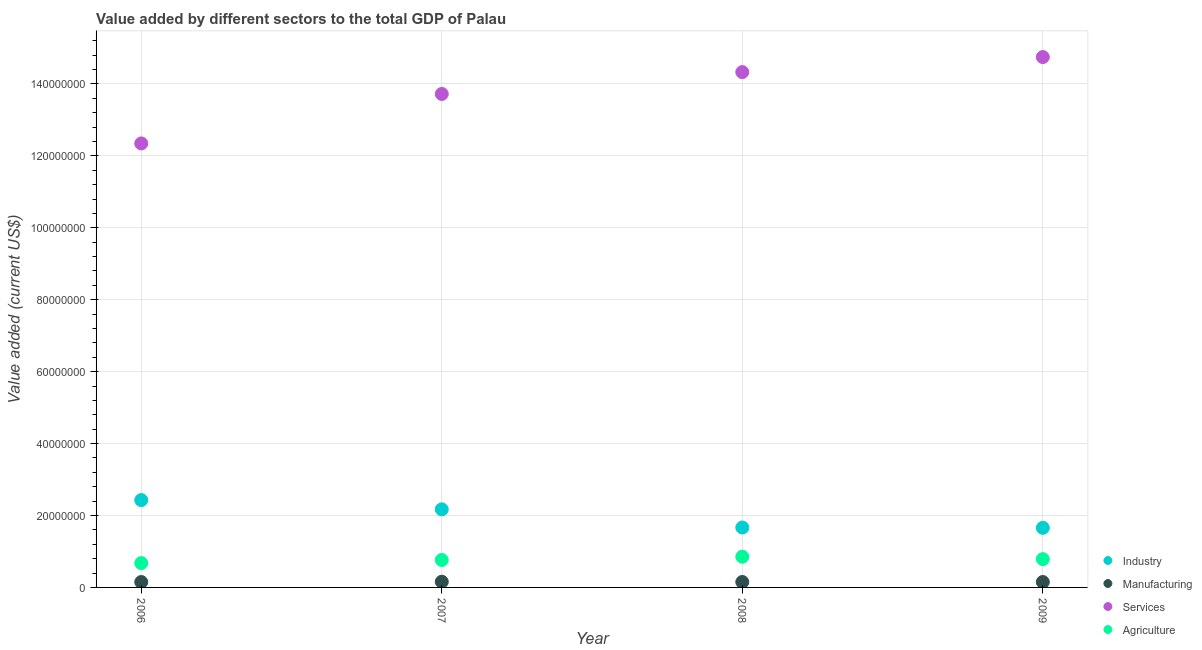How many different coloured dotlines are there?
Make the answer very short. 4. What is the value added by industrial sector in 2008?
Your response must be concise. 1.67e+07. Across all years, what is the maximum value added by manufacturing sector?
Provide a short and direct response. 1.58e+06. Across all years, what is the minimum value added by industrial sector?
Your response must be concise. 1.66e+07. In which year was the value added by manufacturing sector minimum?
Provide a short and direct response. 2006. What is the total value added by manufacturing sector in the graph?
Your answer should be very brief. 6.11e+06. What is the difference between the value added by manufacturing sector in 2006 and that in 2007?
Provide a short and direct response. -8.28e+04. What is the difference between the value added by industrial sector in 2007 and the value added by manufacturing sector in 2006?
Provide a succinct answer. 2.02e+07. What is the average value added by agricultural sector per year?
Offer a very short reply. 7.70e+06. In the year 2009, what is the difference between the value added by industrial sector and value added by agricultural sector?
Your answer should be compact. 8.71e+06. What is the ratio of the value added by agricultural sector in 2006 to that in 2007?
Provide a succinct answer. 0.89. Is the value added by agricultural sector in 2008 less than that in 2009?
Make the answer very short. No. Is the difference between the value added by services sector in 2007 and 2008 greater than the difference between the value added by industrial sector in 2007 and 2008?
Your response must be concise. No. What is the difference between the highest and the second highest value added by industrial sector?
Provide a short and direct response. 2.57e+06. What is the difference between the highest and the lowest value added by industrial sector?
Keep it short and to the point. 7.71e+06. Is the sum of the value added by industrial sector in 2006 and 2009 greater than the maximum value added by manufacturing sector across all years?
Your answer should be compact. Yes. Does the value added by services sector monotonically increase over the years?
Ensure brevity in your answer.  Yes. How many dotlines are there?
Your answer should be compact. 4. How many years are there in the graph?
Your answer should be compact. 4. Does the graph contain any zero values?
Give a very brief answer. No. How are the legend labels stacked?
Your answer should be very brief. Vertical. What is the title of the graph?
Make the answer very short. Value added by different sectors to the total GDP of Palau. Does "Macroeconomic management" appear as one of the legend labels in the graph?
Your answer should be very brief. No. What is the label or title of the Y-axis?
Offer a terse response. Value added (current US$). What is the Value added (current US$) of Industry in 2006?
Provide a succinct answer. 2.43e+07. What is the Value added (current US$) in Manufacturing in 2006?
Your response must be concise. 1.50e+06. What is the Value added (current US$) in Services in 2006?
Ensure brevity in your answer.  1.23e+08. What is the Value added (current US$) in Agriculture in 2006?
Give a very brief answer. 6.77e+06. What is the Value added (current US$) in Industry in 2007?
Your answer should be very brief. 2.17e+07. What is the Value added (current US$) of Manufacturing in 2007?
Keep it short and to the point. 1.58e+06. What is the Value added (current US$) in Services in 2007?
Offer a very short reply. 1.37e+08. What is the Value added (current US$) in Agriculture in 2007?
Ensure brevity in your answer.  7.64e+06. What is the Value added (current US$) in Industry in 2008?
Your answer should be very brief. 1.67e+07. What is the Value added (current US$) in Manufacturing in 2008?
Your answer should be very brief. 1.52e+06. What is the Value added (current US$) in Services in 2008?
Your answer should be very brief. 1.43e+08. What is the Value added (current US$) of Agriculture in 2008?
Your response must be concise. 8.54e+06. What is the Value added (current US$) in Industry in 2009?
Provide a succinct answer. 1.66e+07. What is the Value added (current US$) in Manufacturing in 2009?
Keep it short and to the point. 1.51e+06. What is the Value added (current US$) in Services in 2009?
Provide a succinct answer. 1.47e+08. What is the Value added (current US$) of Agriculture in 2009?
Provide a short and direct response. 7.87e+06. Across all years, what is the maximum Value added (current US$) of Industry?
Make the answer very short. 2.43e+07. Across all years, what is the maximum Value added (current US$) of Manufacturing?
Provide a succinct answer. 1.58e+06. Across all years, what is the maximum Value added (current US$) of Services?
Provide a short and direct response. 1.47e+08. Across all years, what is the maximum Value added (current US$) in Agriculture?
Keep it short and to the point. 8.54e+06. Across all years, what is the minimum Value added (current US$) in Industry?
Your response must be concise. 1.66e+07. Across all years, what is the minimum Value added (current US$) of Manufacturing?
Ensure brevity in your answer.  1.50e+06. Across all years, what is the minimum Value added (current US$) of Services?
Give a very brief answer. 1.23e+08. Across all years, what is the minimum Value added (current US$) in Agriculture?
Ensure brevity in your answer.  6.77e+06. What is the total Value added (current US$) in Industry in the graph?
Give a very brief answer. 7.92e+07. What is the total Value added (current US$) in Manufacturing in the graph?
Ensure brevity in your answer.  6.11e+06. What is the total Value added (current US$) of Services in the graph?
Give a very brief answer. 5.51e+08. What is the total Value added (current US$) in Agriculture in the graph?
Provide a succinct answer. 3.08e+07. What is the difference between the Value added (current US$) in Industry in 2006 and that in 2007?
Make the answer very short. 2.57e+06. What is the difference between the Value added (current US$) of Manufacturing in 2006 and that in 2007?
Keep it short and to the point. -8.28e+04. What is the difference between the Value added (current US$) in Services in 2006 and that in 2007?
Offer a terse response. -1.38e+07. What is the difference between the Value added (current US$) of Agriculture in 2006 and that in 2007?
Make the answer very short. -8.74e+05. What is the difference between the Value added (current US$) in Industry in 2006 and that in 2008?
Provide a short and direct response. 7.63e+06. What is the difference between the Value added (current US$) of Manufacturing in 2006 and that in 2008?
Provide a succinct answer. -1.44e+04. What is the difference between the Value added (current US$) of Services in 2006 and that in 2008?
Keep it short and to the point. -1.98e+07. What is the difference between the Value added (current US$) in Agriculture in 2006 and that in 2008?
Provide a short and direct response. -1.77e+06. What is the difference between the Value added (current US$) of Industry in 2006 and that in 2009?
Your answer should be compact. 7.71e+06. What is the difference between the Value added (current US$) of Manufacturing in 2006 and that in 2009?
Offer a very short reply. -5421.84. What is the difference between the Value added (current US$) of Services in 2006 and that in 2009?
Your answer should be compact. -2.40e+07. What is the difference between the Value added (current US$) of Agriculture in 2006 and that in 2009?
Your response must be concise. -1.10e+06. What is the difference between the Value added (current US$) of Industry in 2007 and that in 2008?
Make the answer very short. 5.05e+06. What is the difference between the Value added (current US$) in Manufacturing in 2007 and that in 2008?
Ensure brevity in your answer.  6.84e+04. What is the difference between the Value added (current US$) of Services in 2007 and that in 2008?
Offer a terse response. -6.07e+06. What is the difference between the Value added (current US$) in Agriculture in 2007 and that in 2008?
Make the answer very short. -9.01e+05. What is the difference between the Value added (current US$) of Industry in 2007 and that in 2009?
Ensure brevity in your answer.  5.14e+06. What is the difference between the Value added (current US$) in Manufacturing in 2007 and that in 2009?
Your response must be concise. 7.73e+04. What is the difference between the Value added (current US$) of Services in 2007 and that in 2009?
Your answer should be compact. -1.03e+07. What is the difference between the Value added (current US$) of Agriculture in 2007 and that in 2009?
Provide a succinct answer. -2.30e+05. What is the difference between the Value added (current US$) of Industry in 2008 and that in 2009?
Offer a very short reply. 8.72e+04. What is the difference between the Value added (current US$) in Manufacturing in 2008 and that in 2009?
Make the answer very short. 8954.61. What is the difference between the Value added (current US$) of Services in 2008 and that in 2009?
Give a very brief answer. -4.18e+06. What is the difference between the Value added (current US$) of Agriculture in 2008 and that in 2009?
Provide a succinct answer. 6.71e+05. What is the difference between the Value added (current US$) in Industry in 2006 and the Value added (current US$) in Manufacturing in 2007?
Keep it short and to the point. 2.27e+07. What is the difference between the Value added (current US$) in Industry in 2006 and the Value added (current US$) in Services in 2007?
Provide a short and direct response. -1.13e+08. What is the difference between the Value added (current US$) of Industry in 2006 and the Value added (current US$) of Agriculture in 2007?
Provide a short and direct response. 1.67e+07. What is the difference between the Value added (current US$) of Manufacturing in 2006 and the Value added (current US$) of Services in 2007?
Provide a short and direct response. -1.36e+08. What is the difference between the Value added (current US$) of Manufacturing in 2006 and the Value added (current US$) of Agriculture in 2007?
Offer a terse response. -6.14e+06. What is the difference between the Value added (current US$) of Services in 2006 and the Value added (current US$) of Agriculture in 2007?
Make the answer very short. 1.16e+08. What is the difference between the Value added (current US$) of Industry in 2006 and the Value added (current US$) of Manufacturing in 2008?
Your answer should be compact. 2.28e+07. What is the difference between the Value added (current US$) of Industry in 2006 and the Value added (current US$) of Services in 2008?
Your answer should be compact. -1.19e+08. What is the difference between the Value added (current US$) in Industry in 2006 and the Value added (current US$) in Agriculture in 2008?
Offer a terse response. 1.57e+07. What is the difference between the Value added (current US$) in Manufacturing in 2006 and the Value added (current US$) in Services in 2008?
Provide a succinct answer. -1.42e+08. What is the difference between the Value added (current US$) of Manufacturing in 2006 and the Value added (current US$) of Agriculture in 2008?
Your answer should be compact. -7.04e+06. What is the difference between the Value added (current US$) in Services in 2006 and the Value added (current US$) in Agriculture in 2008?
Offer a very short reply. 1.15e+08. What is the difference between the Value added (current US$) of Industry in 2006 and the Value added (current US$) of Manufacturing in 2009?
Your response must be concise. 2.28e+07. What is the difference between the Value added (current US$) in Industry in 2006 and the Value added (current US$) in Services in 2009?
Your answer should be compact. -1.23e+08. What is the difference between the Value added (current US$) in Industry in 2006 and the Value added (current US$) in Agriculture in 2009?
Keep it short and to the point. 1.64e+07. What is the difference between the Value added (current US$) of Manufacturing in 2006 and the Value added (current US$) of Services in 2009?
Offer a terse response. -1.46e+08. What is the difference between the Value added (current US$) of Manufacturing in 2006 and the Value added (current US$) of Agriculture in 2009?
Your answer should be very brief. -6.37e+06. What is the difference between the Value added (current US$) in Services in 2006 and the Value added (current US$) in Agriculture in 2009?
Ensure brevity in your answer.  1.16e+08. What is the difference between the Value added (current US$) of Industry in 2007 and the Value added (current US$) of Manufacturing in 2008?
Your answer should be very brief. 2.02e+07. What is the difference between the Value added (current US$) in Industry in 2007 and the Value added (current US$) in Services in 2008?
Your answer should be compact. -1.22e+08. What is the difference between the Value added (current US$) in Industry in 2007 and the Value added (current US$) in Agriculture in 2008?
Ensure brevity in your answer.  1.32e+07. What is the difference between the Value added (current US$) in Manufacturing in 2007 and the Value added (current US$) in Services in 2008?
Offer a very short reply. -1.42e+08. What is the difference between the Value added (current US$) of Manufacturing in 2007 and the Value added (current US$) of Agriculture in 2008?
Your response must be concise. -6.96e+06. What is the difference between the Value added (current US$) in Services in 2007 and the Value added (current US$) in Agriculture in 2008?
Offer a very short reply. 1.29e+08. What is the difference between the Value added (current US$) in Industry in 2007 and the Value added (current US$) in Manufacturing in 2009?
Give a very brief answer. 2.02e+07. What is the difference between the Value added (current US$) of Industry in 2007 and the Value added (current US$) of Services in 2009?
Provide a short and direct response. -1.26e+08. What is the difference between the Value added (current US$) of Industry in 2007 and the Value added (current US$) of Agriculture in 2009?
Keep it short and to the point. 1.38e+07. What is the difference between the Value added (current US$) in Manufacturing in 2007 and the Value added (current US$) in Services in 2009?
Offer a very short reply. -1.46e+08. What is the difference between the Value added (current US$) of Manufacturing in 2007 and the Value added (current US$) of Agriculture in 2009?
Your answer should be compact. -6.28e+06. What is the difference between the Value added (current US$) in Services in 2007 and the Value added (current US$) in Agriculture in 2009?
Offer a terse response. 1.29e+08. What is the difference between the Value added (current US$) of Industry in 2008 and the Value added (current US$) of Manufacturing in 2009?
Your answer should be very brief. 1.52e+07. What is the difference between the Value added (current US$) in Industry in 2008 and the Value added (current US$) in Services in 2009?
Keep it short and to the point. -1.31e+08. What is the difference between the Value added (current US$) in Industry in 2008 and the Value added (current US$) in Agriculture in 2009?
Give a very brief answer. 8.79e+06. What is the difference between the Value added (current US$) in Manufacturing in 2008 and the Value added (current US$) in Services in 2009?
Your answer should be compact. -1.46e+08. What is the difference between the Value added (current US$) in Manufacturing in 2008 and the Value added (current US$) in Agriculture in 2009?
Give a very brief answer. -6.35e+06. What is the difference between the Value added (current US$) of Services in 2008 and the Value added (current US$) of Agriculture in 2009?
Offer a terse response. 1.35e+08. What is the average Value added (current US$) of Industry per year?
Ensure brevity in your answer.  1.98e+07. What is the average Value added (current US$) in Manufacturing per year?
Give a very brief answer. 1.53e+06. What is the average Value added (current US$) of Services per year?
Offer a very short reply. 1.38e+08. What is the average Value added (current US$) of Agriculture per year?
Offer a terse response. 7.70e+06. In the year 2006, what is the difference between the Value added (current US$) in Industry and Value added (current US$) in Manufacturing?
Your answer should be very brief. 2.28e+07. In the year 2006, what is the difference between the Value added (current US$) in Industry and Value added (current US$) in Services?
Offer a terse response. -9.92e+07. In the year 2006, what is the difference between the Value added (current US$) in Industry and Value added (current US$) in Agriculture?
Offer a terse response. 1.75e+07. In the year 2006, what is the difference between the Value added (current US$) of Manufacturing and Value added (current US$) of Services?
Give a very brief answer. -1.22e+08. In the year 2006, what is the difference between the Value added (current US$) of Manufacturing and Value added (current US$) of Agriculture?
Provide a succinct answer. -5.26e+06. In the year 2006, what is the difference between the Value added (current US$) in Services and Value added (current US$) in Agriculture?
Keep it short and to the point. 1.17e+08. In the year 2007, what is the difference between the Value added (current US$) of Industry and Value added (current US$) of Manufacturing?
Offer a very short reply. 2.01e+07. In the year 2007, what is the difference between the Value added (current US$) in Industry and Value added (current US$) in Services?
Provide a succinct answer. -1.16e+08. In the year 2007, what is the difference between the Value added (current US$) in Industry and Value added (current US$) in Agriculture?
Provide a short and direct response. 1.41e+07. In the year 2007, what is the difference between the Value added (current US$) of Manufacturing and Value added (current US$) of Services?
Keep it short and to the point. -1.36e+08. In the year 2007, what is the difference between the Value added (current US$) in Manufacturing and Value added (current US$) in Agriculture?
Offer a very short reply. -6.05e+06. In the year 2007, what is the difference between the Value added (current US$) in Services and Value added (current US$) in Agriculture?
Offer a terse response. 1.30e+08. In the year 2008, what is the difference between the Value added (current US$) of Industry and Value added (current US$) of Manufacturing?
Offer a very short reply. 1.51e+07. In the year 2008, what is the difference between the Value added (current US$) of Industry and Value added (current US$) of Services?
Your response must be concise. -1.27e+08. In the year 2008, what is the difference between the Value added (current US$) of Industry and Value added (current US$) of Agriculture?
Ensure brevity in your answer.  8.12e+06. In the year 2008, what is the difference between the Value added (current US$) of Manufacturing and Value added (current US$) of Services?
Provide a short and direct response. -1.42e+08. In the year 2008, what is the difference between the Value added (current US$) of Manufacturing and Value added (current US$) of Agriculture?
Make the answer very short. -7.02e+06. In the year 2008, what is the difference between the Value added (current US$) in Services and Value added (current US$) in Agriculture?
Provide a short and direct response. 1.35e+08. In the year 2009, what is the difference between the Value added (current US$) of Industry and Value added (current US$) of Manufacturing?
Keep it short and to the point. 1.51e+07. In the year 2009, what is the difference between the Value added (current US$) in Industry and Value added (current US$) in Services?
Your response must be concise. -1.31e+08. In the year 2009, what is the difference between the Value added (current US$) of Industry and Value added (current US$) of Agriculture?
Give a very brief answer. 8.71e+06. In the year 2009, what is the difference between the Value added (current US$) in Manufacturing and Value added (current US$) in Services?
Your response must be concise. -1.46e+08. In the year 2009, what is the difference between the Value added (current US$) in Manufacturing and Value added (current US$) in Agriculture?
Offer a terse response. -6.36e+06. In the year 2009, what is the difference between the Value added (current US$) of Services and Value added (current US$) of Agriculture?
Your response must be concise. 1.40e+08. What is the ratio of the Value added (current US$) in Industry in 2006 to that in 2007?
Your answer should be compact. 1.12. What is the ratio of the Value added (current US$) in Manufacturing in 2006 to that in 2007?
Your response must be concise. 0.95. What is the ratio of the Value added (current US$) in Services in 2006 to that in 2007?
Your answer should be very brief. 0.9. What is the ratio of the Value added (current US$) of Agriculture in 2006 to that in 2007?
Offer a very short reply. 0.89. What is the ratio of the Value added (current US$) of Industry in 2006 to that in 2008?
Keep it short and to the point. 1.46. What is the ratio of the Value added (current US$) in Manufacturing in 2006 to that in 2008?
Your answer should be very brief. 0.99. What is the ratio of the Value added (current US$) of Services in 2006 to that in 2008?
Provide a short and direct response. 0.86. What is the ratio of the Value added (current US$) in Agriculture in 2006 to that in 2008?
Provide a short and direct response. 0.79. What is the ratio of the Value added (current US$) of Industry in 2006 to that in 2009?
Provide a succinct answer. 1.47. What is the ratio of the Value added (current US$) in Services in 2006 to that in 2009?
Provide a short and direct response. 0.84. What is the ratio of the Value added (current US$) in Agriculture in 2006 to that in 2009?
Provide a succinct answer. 0.86. What is the ratio of the Value added (current US$) in Industry in 2007 to that in 2008?
Keep it short and to the point. 1.3. What is the ratio of the Value added (current US$) in Manufacturing in 2007 to that in 2008?
Keep it short and to the point. 1.05. What is the ratio of the Value added (current US$) of Services in 2007 to that in 2008?
Make the answer very short. 0.96. What is the ratio of the Value added (current US$) of Agriculture in 2007 to that in 2008?
Offer a terse response. 0.89. What is the ratio of the Value added (current US$) of Industry in 2007 to that in 2009?
Offer a terse response. 1.31. What is the ratio of the Value added (current US$) in Manufacturing in 2007 to that in 2009?
Your response must be concise. 1.05. What is the ratio of the Value added (current US$) in Services in 2007 to that in 2009?
Give a very brief answer. 0.93. What is the ratio of the Value added (current US$) of Agriculture in 2007 to that in 2009?
Give a very brief answer. 0.97. What is the ratio of the Value added (current US$) of Manufacturing in 2008 to that in 2009?
Provide a short and direct response. 1.01. What is the ratio of the Value added (current US$) of Services in 2008 to that in 2009?
Make the answer very short. 0.97. What is the ratio of the Value added (current US$) of Agriculture in 2008 to that in 2009?
Your answer should be very brief. 1.09. What is the difference between the highest and the second highest Value added (current US$) of Industry?
Offer a terse response. 2.57e+06. What is the difference between the highest and the second highest Value added (current US$) of Manufacturing?
Offer a terse response. 6.84e+04. What is the difference between the highest and the second highest Value added (current US$) in Services?
Ensure brevity in your answer.  4.18e+06. What is the difference between the highest and the second highest Value added (current US$) of Agriculture?
Your answer should be compact. 6.71e+05. What is the difference between the highest and the lowest Value added (current US$) in Industry?
Make the answer very short. 7.71e+06. What is the difference between the highest and the lowest Value added (current US$) in Manufacturing?
Make the answer very short. 8.28e+04. What is the difference between the highest and the lowest Value added (current US$) in Services?
Your answer should be very brief. 2.40e+07. What is the difference between the highest and the lowest Value added (current US$) of Agriculture?
Your answer should be very brief. 1.77e+06. 